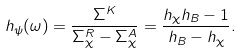Convert formula to latex. <formula><loc_0><loc_0><loc_500><loc_500>h _ { \psi } ( \omega ) = \frac { \Sigma ^ { K } } { \Sigma _ { \chi } ^ { R } - \Sigma _ { \chi } ^ { A } } = \frac { h _ { \chi } h _ { B } - 1 } { h _ { B } - h _ { \chi } } .</formula> 